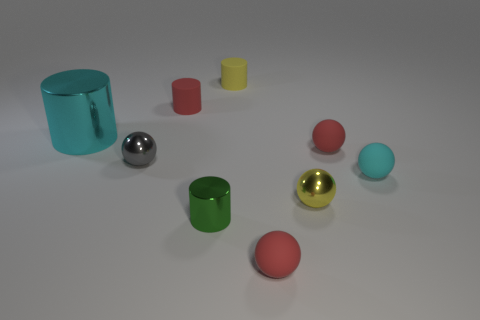There is a tiny rubber thing that is the same color as the big metal cylinder; what is its shape?
Your answer should be very brief. Sphere. How many cyan things are in front of the small red cylinder that is behind the tiny metallic sphere that is to the left of the red cylinder?
Offer a very short reply. 2. There is a matte object in front of the small yellow metallic object; is it the same color as the rubber sphere that is behind the gray metallic object?
Provide a short and direct response. Yes. Is there any other thing that has the same color as the small metal cylinder?
Make the answer very short. No. What color is the metallic cylinder that is in front of the large cyan metal thing that is behind the gray metallic ball?
Make the answer very short. Green. Are there any large gray things?
Offer a terse response. No. The small cylinder that is both behind the tiny cyan matte object and in front of the tiny yellow cylinder is what color?
Keep it short and to the point. Red. Does the red matte sphere on the right side of the small yellow shiny ball have the same size as the rubber cylinder in front of the small yellow cylinder?
Offer a terse response. Yes. What number of other objects are the same size as the red rubber cylinder?
Make the answer very short. 7. There is a rubber cylinder that is in front of the yellow rubber object; what number of green objects are behind it?
Ensure brevity in your answer.  0. 